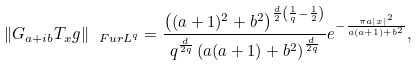Convert formula to latex. <formula><loc_0><loc_0><loc_500><loc_500>\| G _ { a + i b } T _ { x } g \| _ { \ F u r L ^ { q } } = \frac { \left ( ( a + 1 ) ^ { 2 } + b ^ { 2 } \right ) ^ { \frac { d } { 2 } \left ( \frac { 1 } { q } - \frac { 1 } { 2 } \right ) } } { q ^ { \frac { d } { 2 q } } \left ( a ( a + 1 ) + b ^ { 2 } \right ) ^ { \frac { d } { 2 q } } } e ^ { - \frac { \pi a | x | ^ { 2 } } { a ( a + 1 ) + b ^ { 2 } } } ,</formula> 